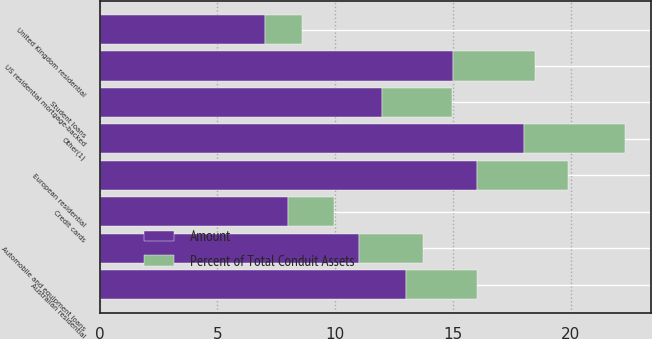Convert chart to OTSL. <chart><loc_0><loc_0><loc_500><loc_500><stacked_bar_chart><ecel><fcel>Australian residential<fcel>European residential<fcel>US residential mortgage-backed<fcel>United Kingdom residential<fcel>Student loans<fcel>Automobile and equipment loans<fcel>Credit cards<fcel>Other(1)<nl><fcel>Percent of Total Conduit Assets<fcel>3.03<fcel>3.88<fcel>3.49<fcel>1.57<fcel>2.94<fcel>2.72<fcel>1.96<fcel>4.3<nl><fcel>Amount<fcel>13<fcel>16<fcel>15<fcel>7<fcel>12<fcel>11<fcel>8<fcel>18<nl></chart> 